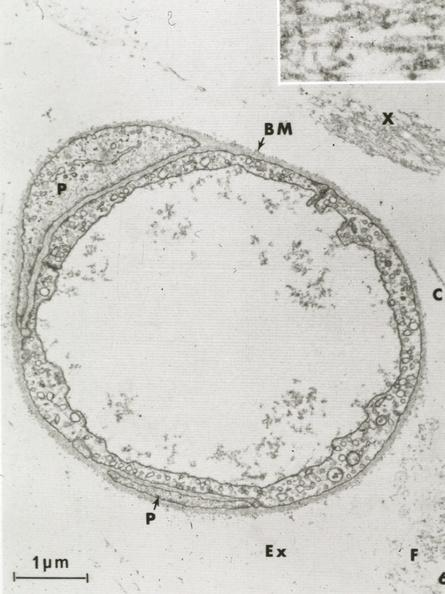does this image show continuous type?
Answer the question using a single word or phrase. Yes 